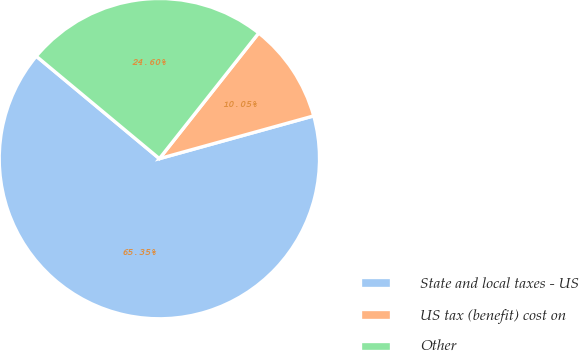Convert chart to OTSL. <chart><loc_0><loc_0><loc_500><loc_500><pie_chart><fcel>State and local taxes - US<fcel>US tax (benefit) cost on<fcel>Other<nl><fcel>65.34%<fcel>10.05%<fcel>24.6%<nl></chart> 